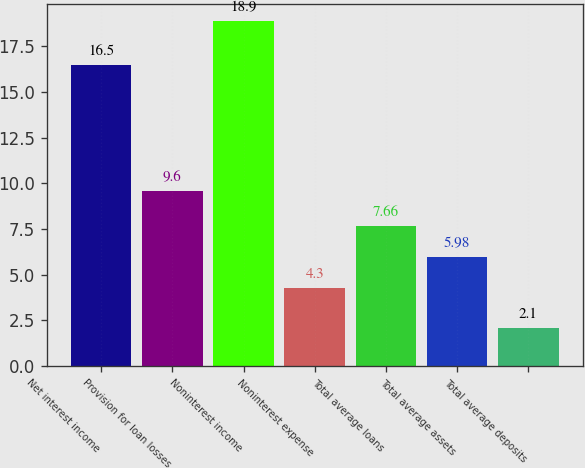Convert chart to OTSL. <chart><loc_0><loc_0><loc_500><loc_500><bar_chart><fcel>Net interest income<fcel>Provision for loan losses<fcel>Noninterest income<fcel>Noninterest expense<fcel>Total average loans<fcel>Total average assets<fcel>Total average deposits<nl><fcel>16.5<fcel>9.6<fcel>18.9<fcel>4.3<fcel>7.66<fcel>5.98<fcel>2.1<nl></chart> 